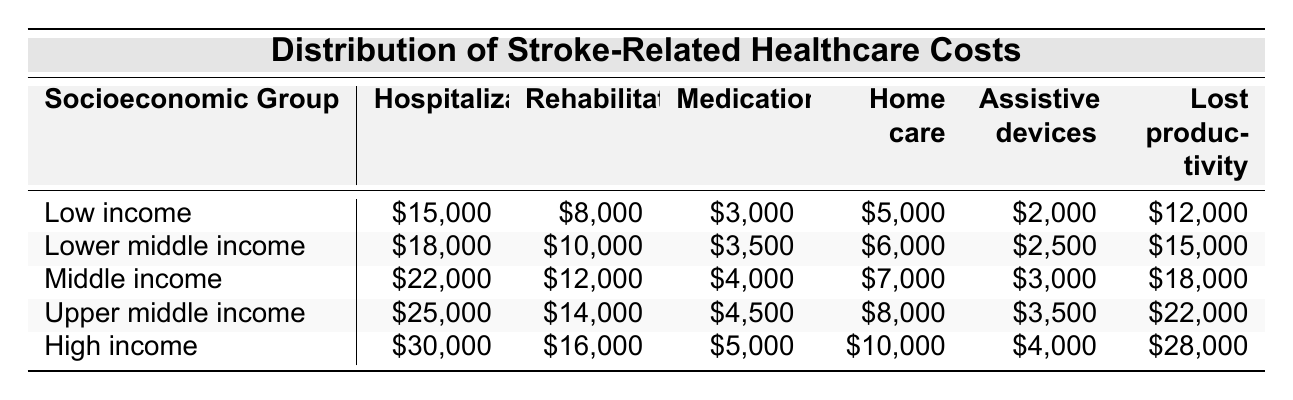What is the hospitalization cost for the high-income group? The high-income group has a hospitalization cost listed directly in the table as \$30,000.
Answer: \$30,000 Which socioeconomic group has the highest rehabilitation cost? The table shows that the high-income group also has the highest rehabilitation cost of \$16,000.
Answer: High income What is the total cost of medications for all groups combined? By adding the costs: 3000 + 3500 + 4000 + 4500 + 5000 = 22500, we find that the total cost is \$22,500.
Answer: \$22,500 Is the lost productivity cost for the lower middle income group greater than that for the low income group? The lost productivity for the lower middle income group is \$15,000, while for the low income group it is \$12,000; thus, the statement is true.
Answer: Yes What is the difference in hospitalization costs between the upper middle income and middle income groups? The hospitalization cost for the upper middle income is \$25,000 and for the middle income is \$22,000. The difference is \$25,000 - \$22,000 = \$3,000.
Answer: \$3,000 Calculate the average home care cost across all socioeconomic groups. The home care costs are 5000, 6000, 7000, 8000, and 10000. Summing these gives 5000 + 6000 + 7000 + 8000 + 10000 = 40000, then averaging this over 5 groups results in 40000 / 5 = 8000.
Answer: \$8,000 Which cost category shows the smallest amount for the low income group? In the table, the assistive devices cost for the low income group is \$2,000, which is the lowest compared to other categories.
Answer: Assistive devices How much more do high income individuals spend on lost productivity compared to low income individuals? The high income lost productivity cost is \$28,000 and low income is \$12,000. The difference is \$28,000 - \$12,000 = \$16,000.
Answer: \$16,000 Which group has the lowest total healthcare costs among hospitalization, rehabilitation, medications, home care, assistive devices, and lost productivity? The data for low income group shows \$15,000 + \$8,000 + \$3,000 + \$5,000 + \$2,000 + \$12,000 = \$45,000, which is indeed lower than others when calculated.
Answer: Low income Is the average rehabilitation cost across all groups above \$12,000? Summing the rehabilitation costs gives \$8,000 + \$10,000 + \$12,000 + \$14,000 + \$16,000 = \$60,000, and dividing by 5 gives an average of \$12,000; thus, the average is not above \$12,000 and the statement is false.
Answer: No 